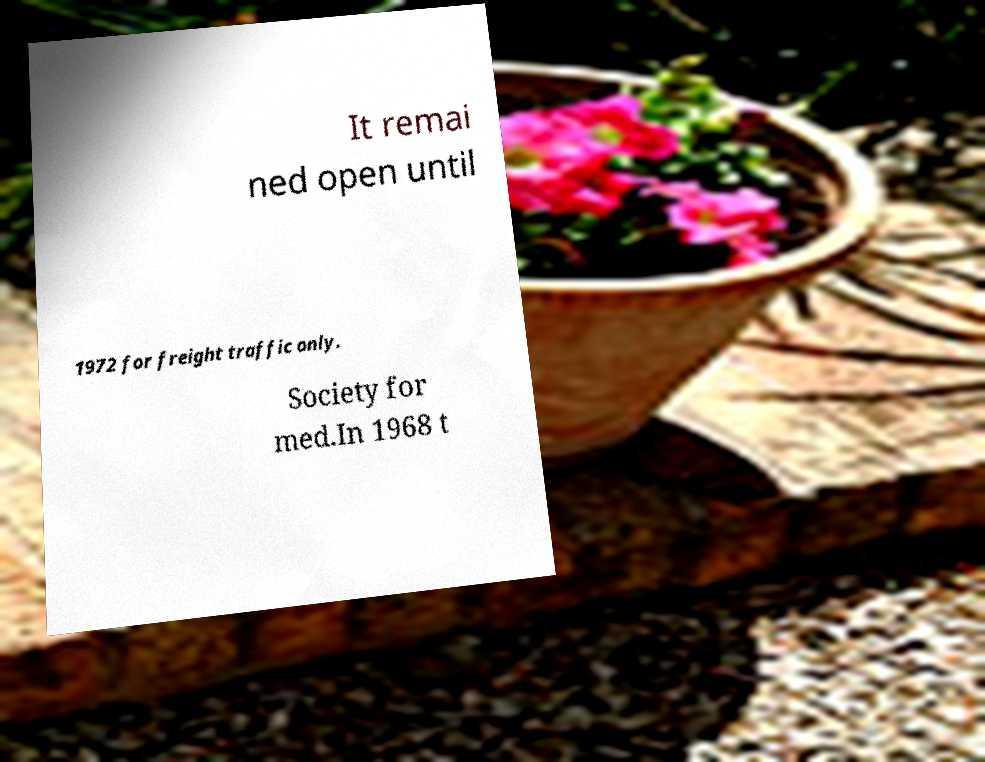For documentation purposes, I need the text within this image transcribed. Could you provide that? It remai ned open until 1972 for freight traffic only. Society for med.In 1968 t 